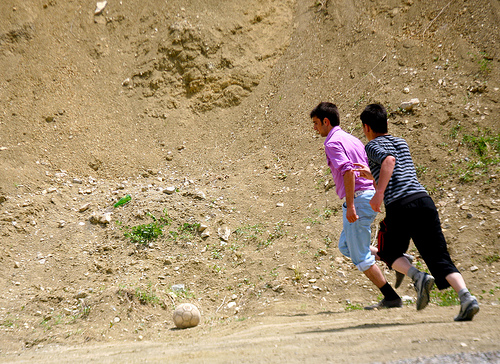<image>
Can you confirm if the man is to the left of the ball? No. The man is not to the left of the ball. From this viewpoint, they have a different horizontal relationship. 